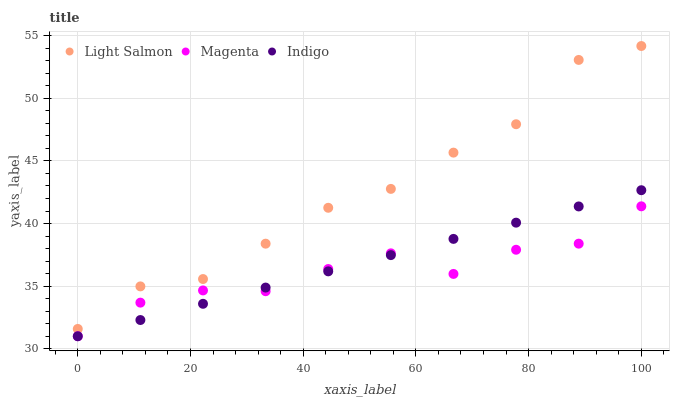Does Magenta have the minimum area under the curve?
Answer yes or no. Yes. Does Light Salmon have the maximum area under the curve?
Answer yes or no. Yes. Does Indigo have the minimum area under the curve?
Answer yes or no. No. Does Indigo have the maximum area under the curve?
Answer yes or no. No. Is Indigo the smoothest?
Answer yes or no. Yes. Is Magenta the roughest?
Answer yes or no. Yes. Is Magenta the smoothest?
Answer yes or no. No. Is Indigo the roughest?
Answer yes or no. No. Does Indigo have the lowest value?
Answer yes or no. Yes. Does Light Salmon have the highest value?
Answer yes or no. Yes. Does Indigo have the highest value?
Answer yes or no. No. Is Magenta less than Light Salmon?
Answer yes or no. Yes. Is Light Salmon greater than Magenta?
Answer yes or no. Yes. Does Indigo intersect Magenta?
Answer yes or no. Yes. Is Indigo less than Magenta?
Answer yes or no. No. Is Indigo greater than Magenta?
Answer yes or no. No. Does Magenta intersect Light Salmon?
Answer yes or no. No. 